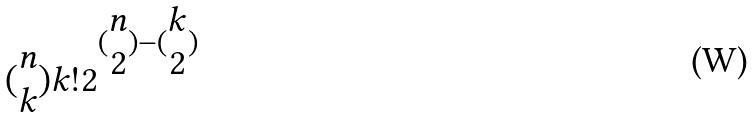Convert formula to latex. <formula><loc_0><loc_0><loc_500><loc_500>( \begin{matrix} n \\ k \end{matrix} ) k ! 2 ^ { ( \begin{matrix} n \\ 2 \end{matrix} ) - ( \begin{matrix} k \\ 2 \end{matrix} ) }</formula> 